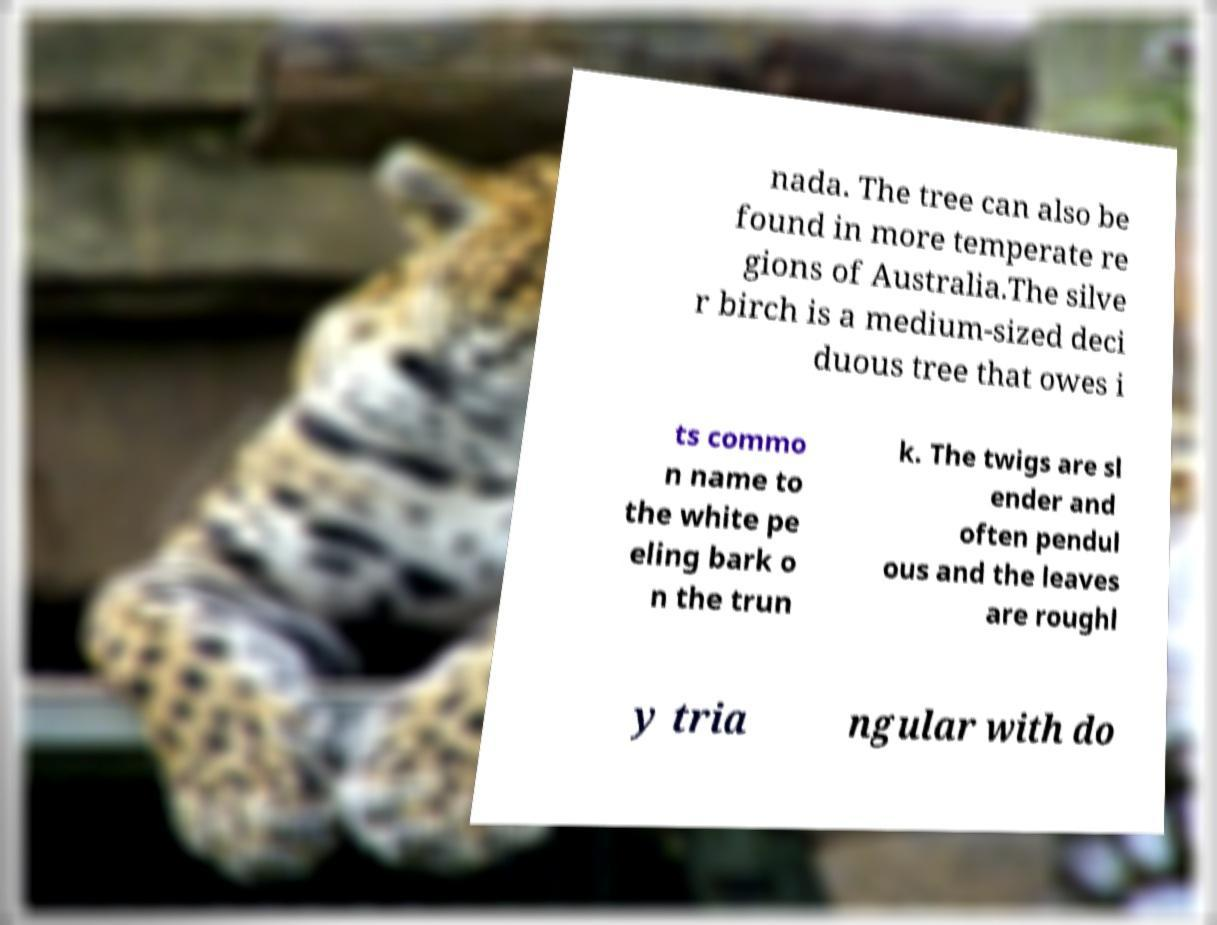What messages or text are displayed in this image? I need them in a readable, typed format. nada. The tree can also be found in more temperate re gions of Australia.The silve r birch is a medium-sized deci duous tree that owes i ts commo n name to the white pe eling bark o n the trun k. The twigs are sl ender and often pendul ous and the leaves are roughl y tria ngular with do 